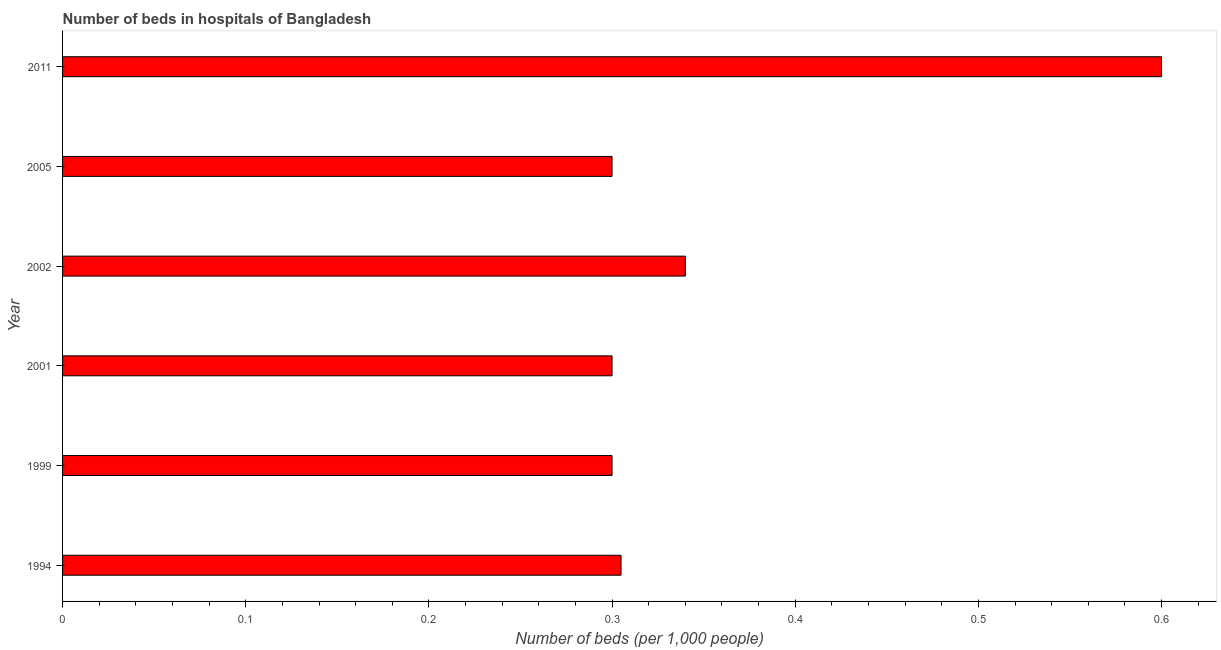Does the graph contain any zero values?
Your response must be concise. No. Does the graph contain grids?
Provide a short and direct response. No. What is the title of the graph?
Make the answer very short. Number of beds in hospitals of Bangladesh. What is the label or title of the X-axis?
Your response must be concise. Number of beds (per 1,0 people). What is the number of hospital beds in 1994?
Offer a very short reply. 0.3. Across all years, what is the minimum number of hospital beds?
Your response must be concise. 0.3. In which year was the number of hospital beds maximum?
Make the answer very short. 2011. In which year was the number of hospital beds minimum?
Keep it short and to the point. 2001. What is the sum of the number of hospital beds?
Ensure brevity in your answer.  2.14. What is the difference between the number of hospital beds in 2002 and 2011?
Offer a very short reply. -0.26. What is the average number of hospital beds per year?
Your answer should be very brief. 0.36. What is the median number of hospital beds?
Your answer should be very brief. 0.3. What is the ratio of the number of hospital beds in 1999 to that in 2001?
Provide a succinct answer. 1. Is the number of hospital beds in 1994 less than that in 2001?
Your answer should be compact. No. What is the difference between the highest and the second highest number of hospital beds?
Offer a very short reply. 0.26. Is the sum of the number of hospital beds in 2005 and 2011 greater than the maximum number of hospital beds across all years?
Give a very brief answer. Yes. How many bars are there?
Ensure brevity in your answer.  6. Are all the bars in the graph horizontal?
Offer a very short reply. Yes. Are the values on the major ticks of X-axis written in scientific E-notation?
Your answer should be compact. No. What is the Number of beds (per 1,000 people) of 1994?
Offer a terse response. 0.3. What is the Number of beds (per 1,000 people) of 1999?
Your response must be concise. 0.3. What is the Number of beds (per 1,000 people) in 2001?
Keep it short and to the point. 0.3. What is the Number of beds (per 1,000 people) in 2002?
Offer a terse response. 0.34. What is the Number of beds (per 1,000 people) in 2011?
Keep it short and to the point. 0.6. What is the difference between the Number of beds (per 1,000 people) in 1994 and 1999?
Your response must be concise. 0. What is the difference between the Number of beds (per 1,000 people) in 1994 and 2001?
Offer a very short reply. 0. What is the difference between the Number of beds (per 1,000 people) in 1994 and 2002?
Your response must be concise. -0.04. What is the difference between the Number of beds (per 1,000 people) in 1994 and 2005?
Your answer should be very brief. 0. What is the difference between the Number of beds (per 1,000 people) in 1994 and 2011?
Provide a short and direct response. -0.3. What is the difference between the Number of beds (per 1,000 people) in 1999 and 2001?
Your answer should be compact. 0. What is the difference between the Number of beds (per 1,000 people) in 1999 and 2002?
Offer a very short reply. -0.04. What is the difference between the Number of beds (per 1,000 people) in 1999 and 2011?
Your response must be concise. -0.3. What is the difference between the Number of beds (per 1,000 people) in 2001 and 2002?
Offer a terse response. -0.04. What is the difference between the Number of beds (per 1,000 people) in 2001 and 2011?
Your answer should be very brief. -0.3. What is the difference between the Number of beds (per 1,000 people) in 2002 and 2005?
Your response must be concise. 0.04. What is the difference between the Number of beds (per 1,000 people) in 2002 and 2011?
Your answer should be compact. -0.26. What is the ratio of the Number of beds (per 1,000 people) in 1994 to that in 2002?
Give a very brief answer. 0.9. What is the ratio of the Number of beds (per 1,000 people) in 1994 to that in 2011?
Your answer should be very brief. 0.51. What is the ratio of the Number of beds (per 1,000 people) in 1999 to that in 2001?
Ensure brevity in your answer.  1. What is the ratio of the Number of beds (per 1,000 people) in 1999 to that in 2002?
Give a very brief answer. 0.88. What is the ratio of the Number of beds (per 1,000 people) in 1999 to that in 2011?
Your answer should be very brief. 0.5. What is the ratio of the Number of beds (per 1,000 people) in 2001 to that in 2002?
Provide a short and direct response. 0.88. What is the ratio of the Number of beds (per 1,000 people) in 2001 to that in 2005?
Your response must be concise. 1. What is the ratio of the Number of beds (per 1,000 people) in 2002 to that in 2005?
Your answer should be compact. 1.13. What is the ratio of the Number of beds (per 1,000 people) in 2002 to that in 2011?
Your answer should be compact. 0.57. What is the ratio of the Number of beds (per 1,000 people) in 2005 to that in 2011?
Provide a short and direct response. 0.5. 